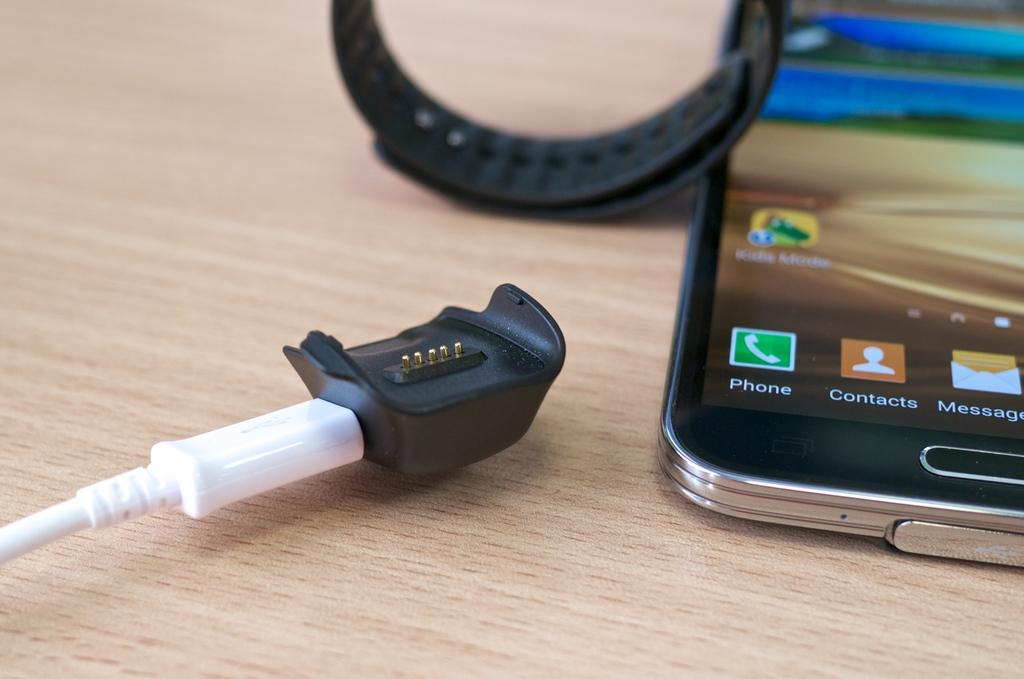<image>
Offer a succinct explanation of the picture presented. Phone, Contacts and Messages are shown as icons on this smart phone. 